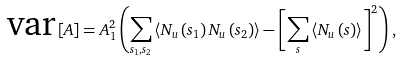<formula> <loc_0><loc_0><loc_500><loc_500>\text {var} \left [ A \right ] = A _ { 1 } ^ { 2 } \left ( \sum _ { s _ { 1 } , s _ { 2 } } \left \langle N _ { u } \left ( s _ { 1 } \right ) N _ { u } \left ( s _ { 2 } \right ) \right \rangle - \left [ \sum _ { s } \left \langle N _ { u } \left ( s \right ) \right \rangle \right ] ^ { 2 } \right ) ,</formula> 